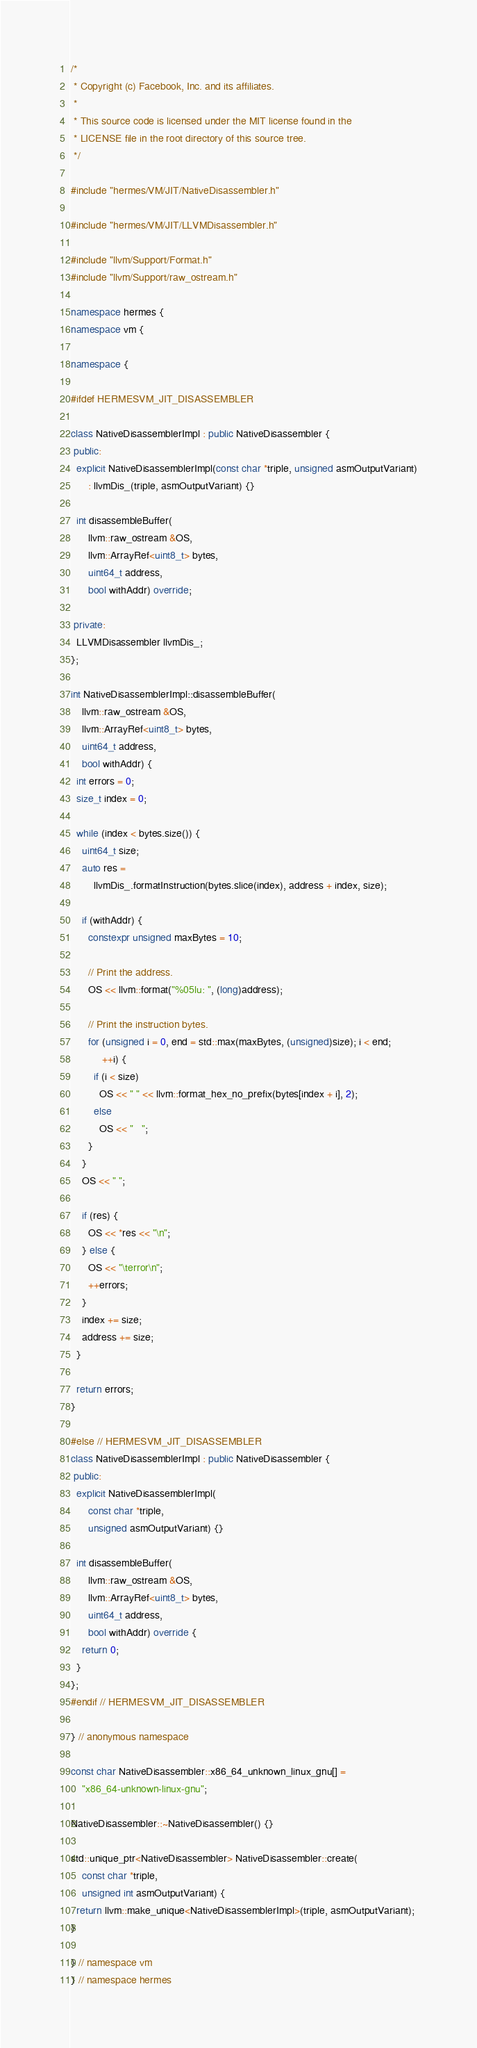Convert code to text. <code><loc_0><loc_0><loc_500><loc_500><_C++_>/*
 * Copyright (c) Facebook, Inc. and its affiliates.
 *
 * This source code is licensed under the MIT license found in the
 * LICENSE file in the root directory of this source tree.
 */

#include "hermes/VM/JIT/NativeDisassembler.h"

#include "hermes/VM/JIT/LLVMDisassembler.h"

#include "llvm/Support/Format.h"
#include "llvm/Support/raw_ostream.h"

namespace hermes {
namespace vm {

namespace {

#ifdef HERMESVM_JIT_DISASSEMBLER

class NativeDisassemblerImpl : public NativeDisassembler {
 public:
  explicit NativeDisassemblerImpl(const char *triple, unsigned asmOutputVariant)
      : llvmDis_(triple, asmOutputVariant) {}

  int disassembleBuffer(
      llvm::raw_ostream &OS,
      llvm::ArrayRef<uint8_t> bytes,
      uint64_t address,
      bool withAddr) override;

 private:
  LLVMDisassembler llvmDis_;
};

int NativeDisassemblerImpl::disassembleBuffer(
    llvm::raw_ostream &OS,
    llvm::ArrayRef<uint8_t> bytes,
    uint64_t address,
    bool withAddr) {
  int errors = 0;
  size_t index = 0;

  while (index < bytes.size()) {
    uint64_t size;
    auto res =
        llvmDis_.formatInstruction(bytes.slice(index), address + index, size);

    if (withAddr) {
      constexpr unsigned maxBytes = 10;

      // Print the address.
      OS << llvm::format("%05lu: ", (long)address);

      // Print the instruction bytes.
      for (unsigned i = 0, end = std::max(maxBytes, (unsigned)size); i < end;
           ++i) {
        if (i < size)
          OS << " " << llvm::format_hex_no_prefix(bytes[index + i], 2);
        else
          OS << "   ";
      }
    }
    OS << " ";

    if (res) {
      OS << *res << "\n";
    } else {
      OS << "\terror\n";
      ++errors;
    }
    index += size;
    address += size;
  }

  return errors;
}

#else // HERMESVM_JIT_DISASSEMBLER
class NativeDisassemblerImpl : public NativeDisassembler {
 public:
  explicit NativeDisassemblerImpl(
      const char *triple,
      unsigned asmOutputVariant) {}

  int disassembleBuffer(
      llvm::raw_ostream &OS,
      llvm::ArrayRef<uint8_t> bytes,
      uint64_t address,
      bool withAddr) override {
    return 0;
  }
};
#endif // HERMESVM_JIT_DISASSEMBLER

} // anonymous namespace

const char NativeDisassembler::x86_64_unknown_linux_gnu[] =
    "x86_64-unknown-linux-gnu";

NativeDisassembler::~NativeDisassembler() {}

std::unique_ptr<NativeDisassembler> NativeDisassembler::create(
    const char *triple,
    unsigned int asmOutputVariant) {
  return llvm::make_unique<NativeDisassemblerImpl>(triple, asmOutputVariant);
}

} // namespace vm
} // namespace hermes
</code> 